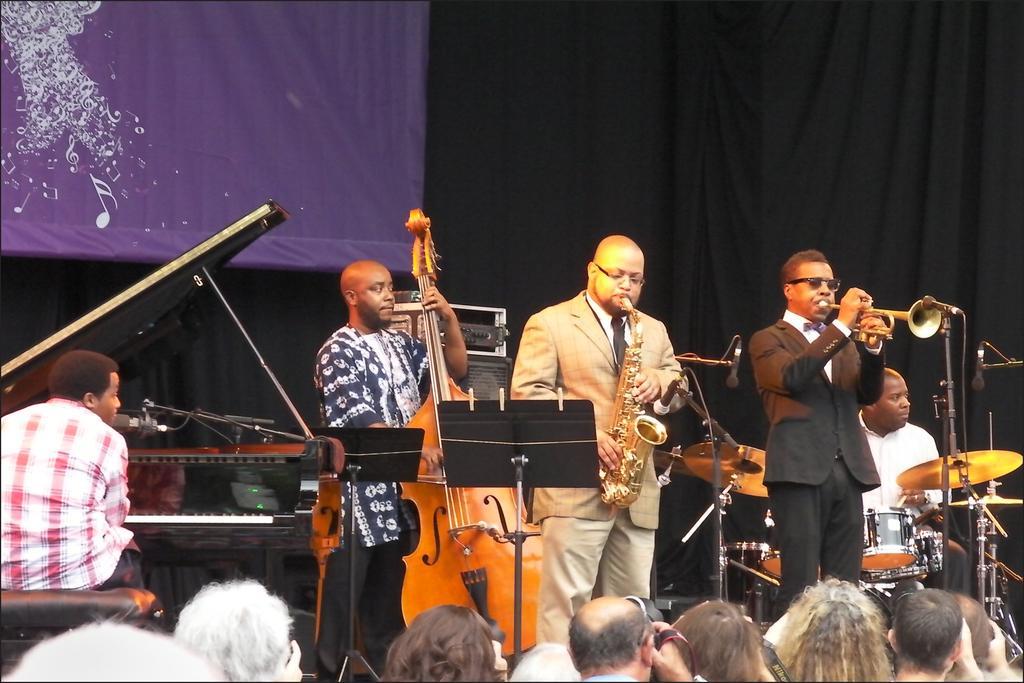Could you give a brief overview of what you see in this image? In this picture we can see some persons standing on the stage and performing the musical band. In the front we can see some audience sitting and listening to them. Behind we can see purple and black curtains. 